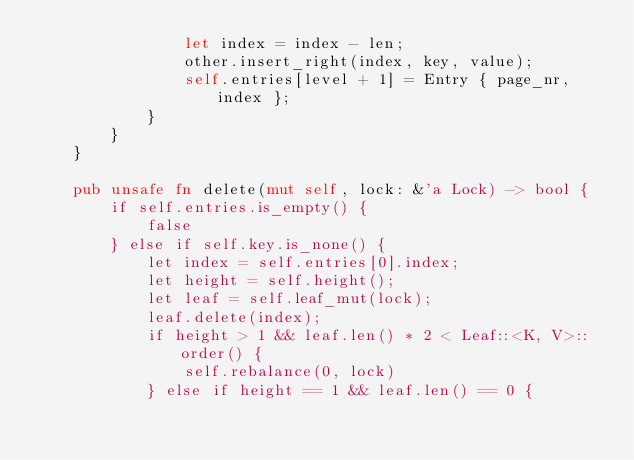<code> <loc_0><loc_0><loc_500><loc_500><_Rust_>                let index = index - len;
                other.insert_right(index, key, value);
                self.entries[level + 1] = Entry { page_nr, index };
            }
        }
    }

    pub unsafe fn delete(mut self, lock: &'a Lock) -> bool {
        if self.entries.is_empty() {
            false
        } else if self.key.is_none() {
            let index = self.entries[0].index;
            let height = self.height();
            let leaf = self.leaf_mut(lock);
            leaf.delete(index);
            if height > 1 && leaf.len() * 2 < Leaf::<K, V>::order() {
                self.rebalance(0, lock)
            } else if height == 1 && leaf.len() == 0 {</code> 